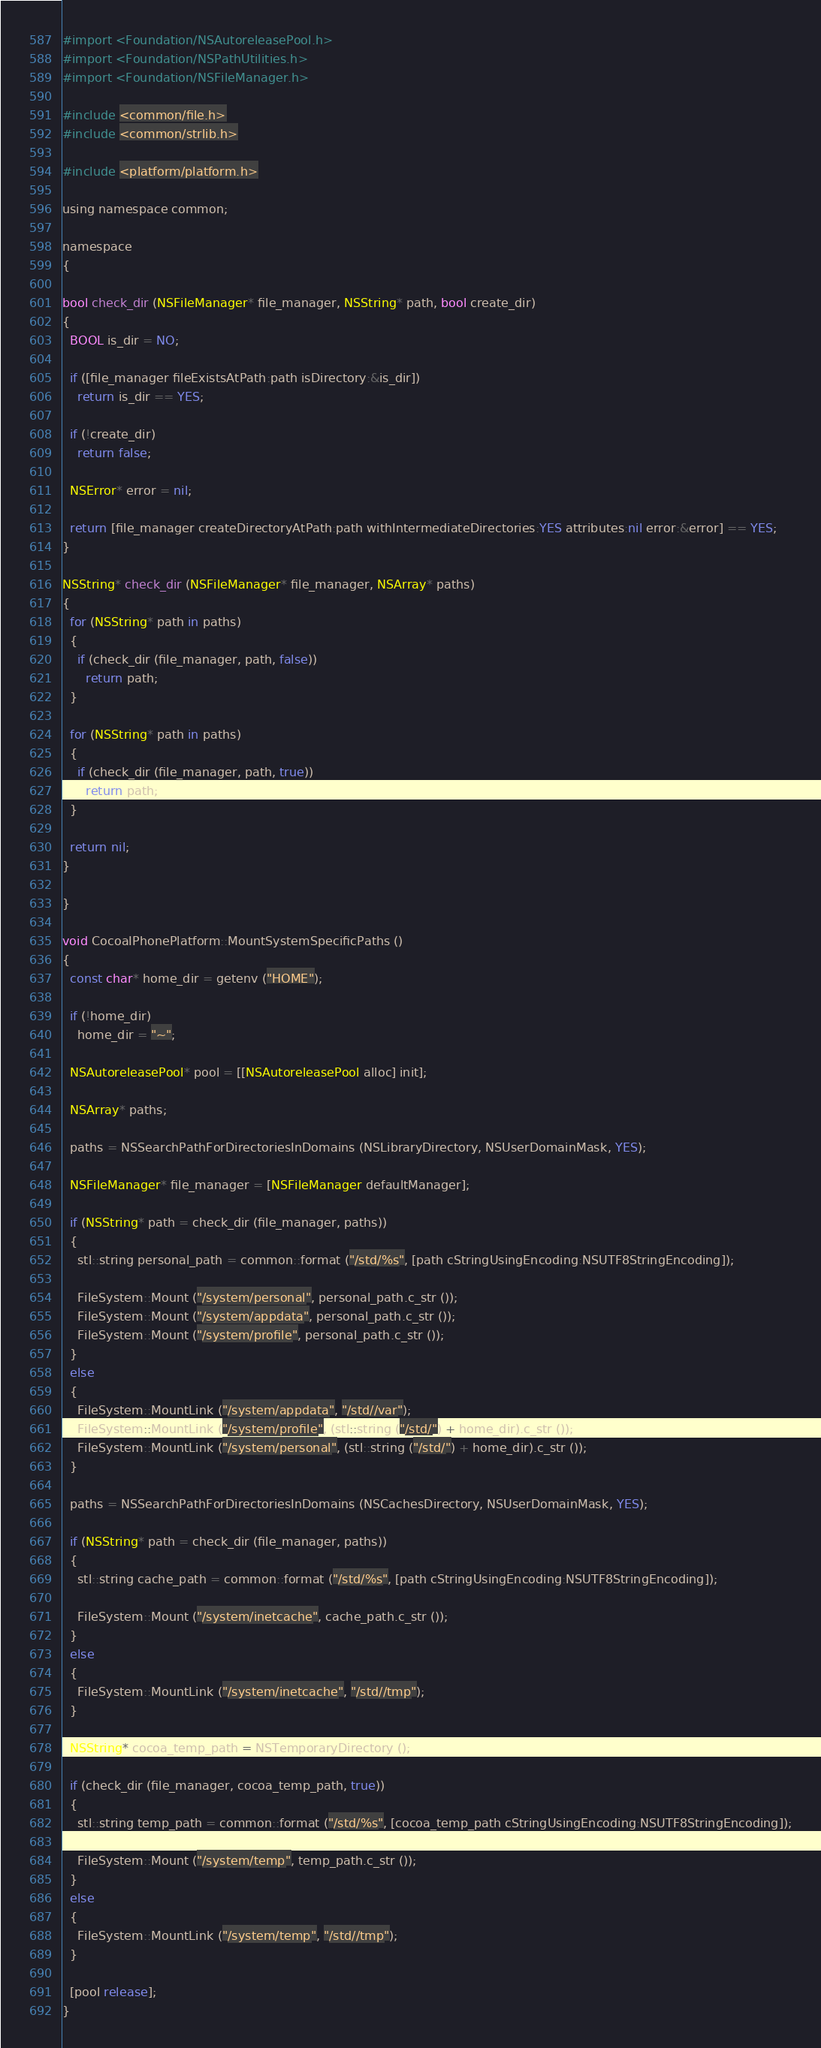Convert code to text. <code><loc_0><loc_0><loc_500><loc_500><_ObjectiveC_>#import <Foundation/NSAutoreleasePool.h>
#import <Foundation/NSPathUtilities.h>
#import <Foundation/NSFileManager.h>

#include <common/file.h>
#include <common/strlib.h>

#include <platform/platform.h>

using namespace common;

namespace
{

bool check_dir (NSFileManager* file_manager, NSString* path, bool create_dir)
{
  BOOL is_dir = NO;

  if ([file_manager fileExistsAtPath:path isDirectory:&is_dir])
    return is_dir == YES;
    
  if (!create_dir)
    return false;

  NSError* error = nil;

  return [file_manager createDirectoryAtPath:path withIntermediateDirectories:YES attributes:nil error:&error] == YES;
}

NSString* check_dir (NSFileManager* file_manager, NSArray* paths)
{
  for (NSString* path in paths)
  {
    if (check_dir (file_manager, path, false))
      return path;
  }

  for (NSString* path in paths)
  {
    if (check_dir (file_manager, path, true))
      return path;
  }
  
  return nil;
}

}

void CocoaIPhonePlatform::MountSystemSpecificPaths ()
{
  const char* home_dir = getenv ("HOME");
    
  if (!home_dir)
    home_dir = "~";

  NSAutoreleasePool* pool = [[NSAutoreleasePool alloc] init];

  NSArray* paths;

  paths = NSSearchPathForDirectoriesInDomains (NSLibraryDirectory, NSUserDomainMask, YES);
  
  NSFileManager* file_manager = [NSFileManager defaultManager];

  if (NSString* path = check_dir (file_manager, paths))
  {
    stl::string personal_path = common::format ("/std/%s", [path cStringUsingEncoding:NSUTF8StringEncoding]);

    FileSystem::Mount ("/system/personal", personal_path.c_str ());
    FileSystem::Mount ("/system/appdata", personal_path.c_str ());
    FileSystem::Mount ("/system/profile", personal_path.c_str ());
  }
  else
  {
    FileSystem::MountLink ("/system/appdata", "/std//var");
    FileSystem::MountLink ("/system/profile", (stl::string ("/std/") + home_dir).c_str ());
    FileSystem::MountLink ("/system/personal", (stl::string ("/std/") + home_dir).c_str ());
  }

  paths = NSSearchPathForDirectoriesInDomains (NSCachesDirectory, NSUserDomainMask, YES);

  if (NSString* path = check_dir (file_manager, paths))
  {
    stl::string cache_path = common::format ("/std/%s", [path cStringUsingEncoding:NSUTF8StringEncoding]);

    FileSystem::Mount ("/system/inetcache", cache_path.c_str ());
  }
  else
  {
    FileSystem::MountLink ("/system/inetcache", "/std//tmp");
  }

  NSString* cocoa_temp_path = NSTemporaryDirectory ();

  if (check_dir (file_manager, cocoa_temp_path, true))
  {    stl::string temp_path = common::format ("/std/%s", [cocoa_temp_path cStringUsingEncoding:NSUTF8StringEncoding]);

    FileSystem::Mount ("/system/temp", temp_path.c_str ());
  }
  else
  {
    FileSystem::MountLink ("/system/temp", "/std//tmp");
  }

  [pool release];
}
</code> 